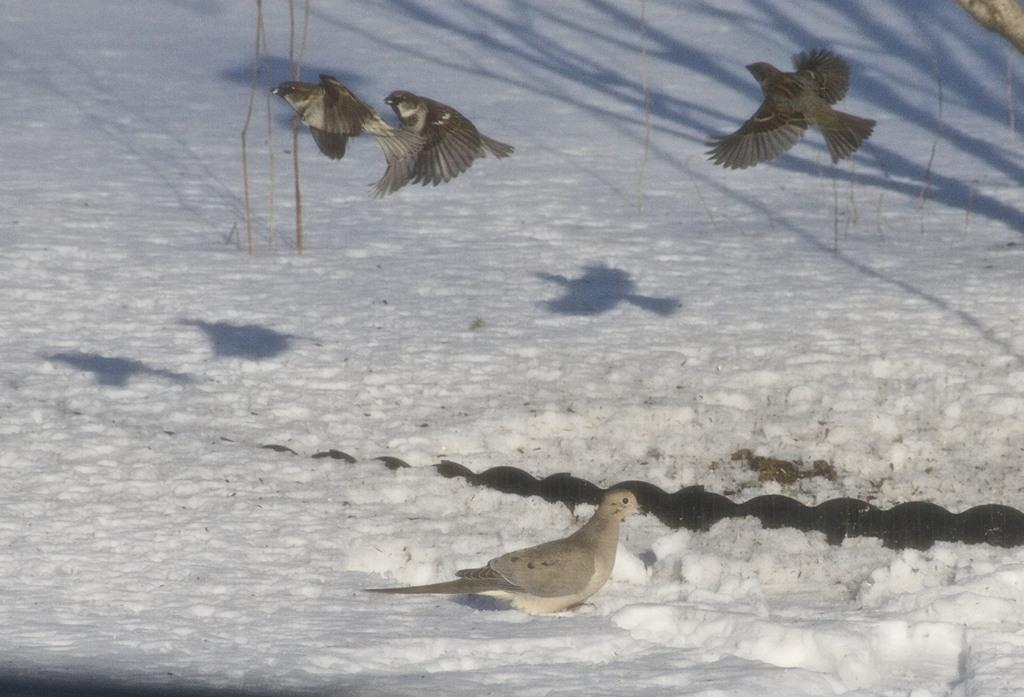What is covering the ground in the image? There is snow on the ground in the image. What is the bird standing on the snow doing? The bird is standing on the snow. How many birds are flying in the air in the image? There are three birds flying in the air in the image. What type of holiday decoration can be seen in the image? There is no holiday decoration present in the image; it features snow, a bird standing on the snow, and three birds flying in the air. 